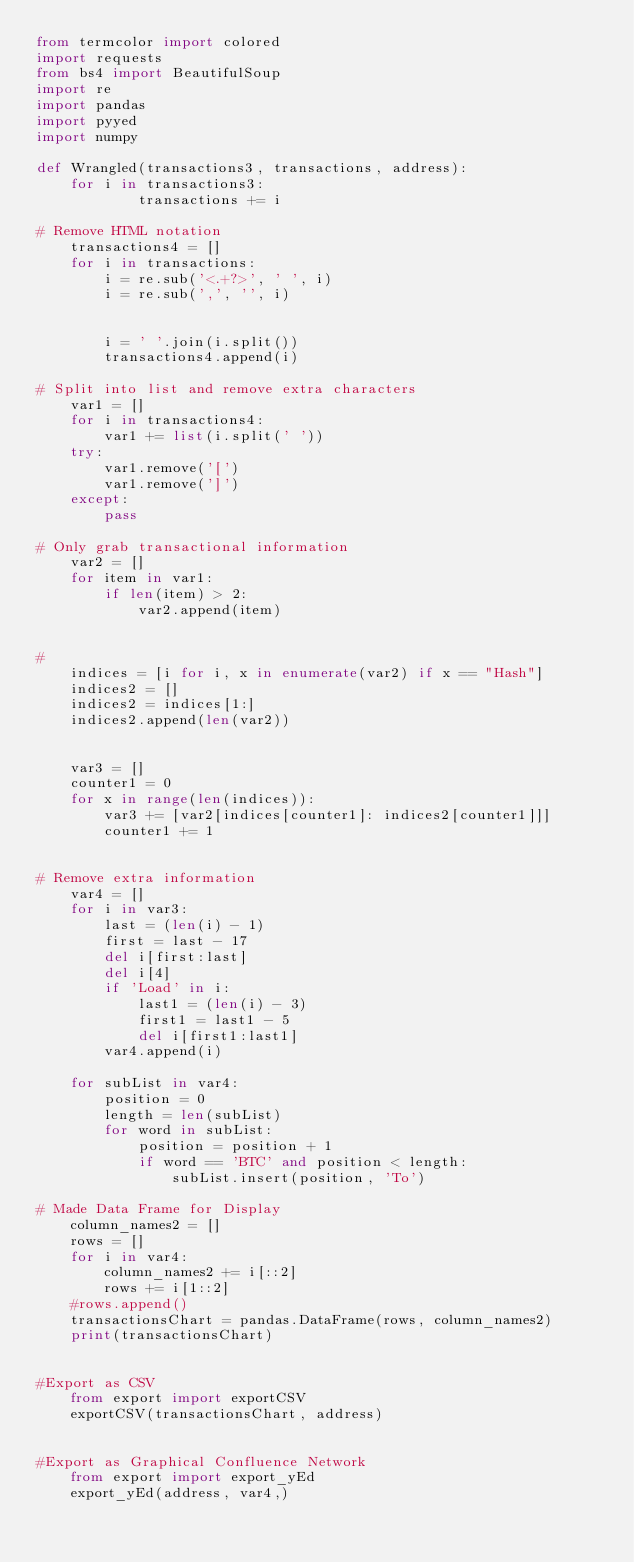Convert code to text. <code><loc_0><loc_0><loc_500><loc_500><_Python_>from termcolor import colored
import requests
from bs4 import BeautifulSoup
import re
import pandas
import pyyed
import numpy

def Wrangled(transactions3, transactions, address):
    for i in transactions3:
            transactions += i

# Remove HTML notation
    transactions4 = []
    for i in transactions:
        i = re.sub('<.+?>', ' ', i)
        i = re.sub(',', '', i)


        i = ' '.join(i.split())
        transactions4.append(i)

# Split into list and remove extra characters
    var1 = []
    for i in transactions4:
        var1 += list(i.split(' '))
    try:
        var1.remove('[')
        var1.remove(']')
    except:
        pass

# Only grab transactional information
    var2 = []
    for item in var1:
        if len(item) > 2:
            var2.append(item)


#
    indices = [i for i, x in enumerate(var2) if x == "Hash"]
    indices2 = []
    indices2 = indices[1:]
    indices2.append(len(var2))


    var3 = []
    counter1 = 0
    for x in range(len(indices)):
        var3 += [var2[indices[counter1]: indices2[counter1]]]
        counter1 += 1


# Remove extra information
    var4 = []
    for i in var3:
        last = (len(i) - 1)
        first = last - 17
        del i[first:last]
        del i[4]
        if 'Load' in i:
            last1 = (len(i) - 3)
            first1 = last1 - 5
            del i[first1:last1]
        var4.append(i)

    for subList in var4:
        position = 0
        length = len(subList)
        for word in subList:
            position = position + 1
            if word == 'BTC' and position < length:
                subList.insert(position, 'To')

# Made Data Frame for Display
    column_names2 = []
    rows = []
    for i in var4:
        column_names2 += i[::2]
        rows += i[1::2]
    #rows.append()
    transactionsChart = pandas.DataFrame(rows, column_names2)
    print(transactionsChart)


#Export as CSV
    from export import exportCSV
    exportCSV(transactionsChart, address)


#Export as Graphical Confluence Network
    from export import export_yEd
    export_yEd(address, var4,)</code> 